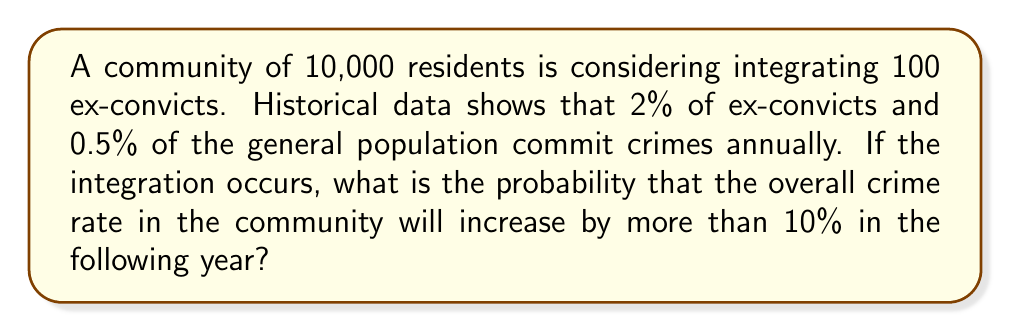Could you help me with this problem? Let's approach this step-by-step:

1) First, let's calculate the current number of crimes in the community:
   $10,000 \times 0.005 = 50$ crimes per year

2) Now, let's calculate the expected number of crimes after integration:
   From general population: $10,000 \times 0.005 = 50$
   From ex-convicts: $100 \times 0.02 = 2$
   Total: $50 + 2 = 52$ crimes per year

3) The new crime rate would be:
   $\frac{52}{10,100} \approx 0.00515$ or 0.515%

4) This is an increase of:
   $\frac{0.00515 - 0.005}{0.005} \times 100\% = 3\%$

5) The question asks for the probability of an increase of more than 10%. Since the expected increase is only 3%, this would require significantly more crimes than expected.

6) To increase by more than 10%, we need more than 55 crimes (50 * 1.1 = 55).

7) We can model this as a Poisson distribution with $\lambda = 52$ (the expected number of crimes).

8) The probability of more than 55 crimes is:
   $P(X > 55) = 1 - P(X \leq 55)$

9) Using the cumulative distribution function of the Poisson distribution:
   $P(X \leq 55) = e^{-52} \sum_{k=0}^{55} \frac{52^k}{k!}$

10) Calculating this (using a calculator or computer):
    $P(X \leq 55) \approx 0.7107$

11) Therefore, $P(X > 55) = 1 - 0.7107 = 0.2893$
Answer: 0.2893 